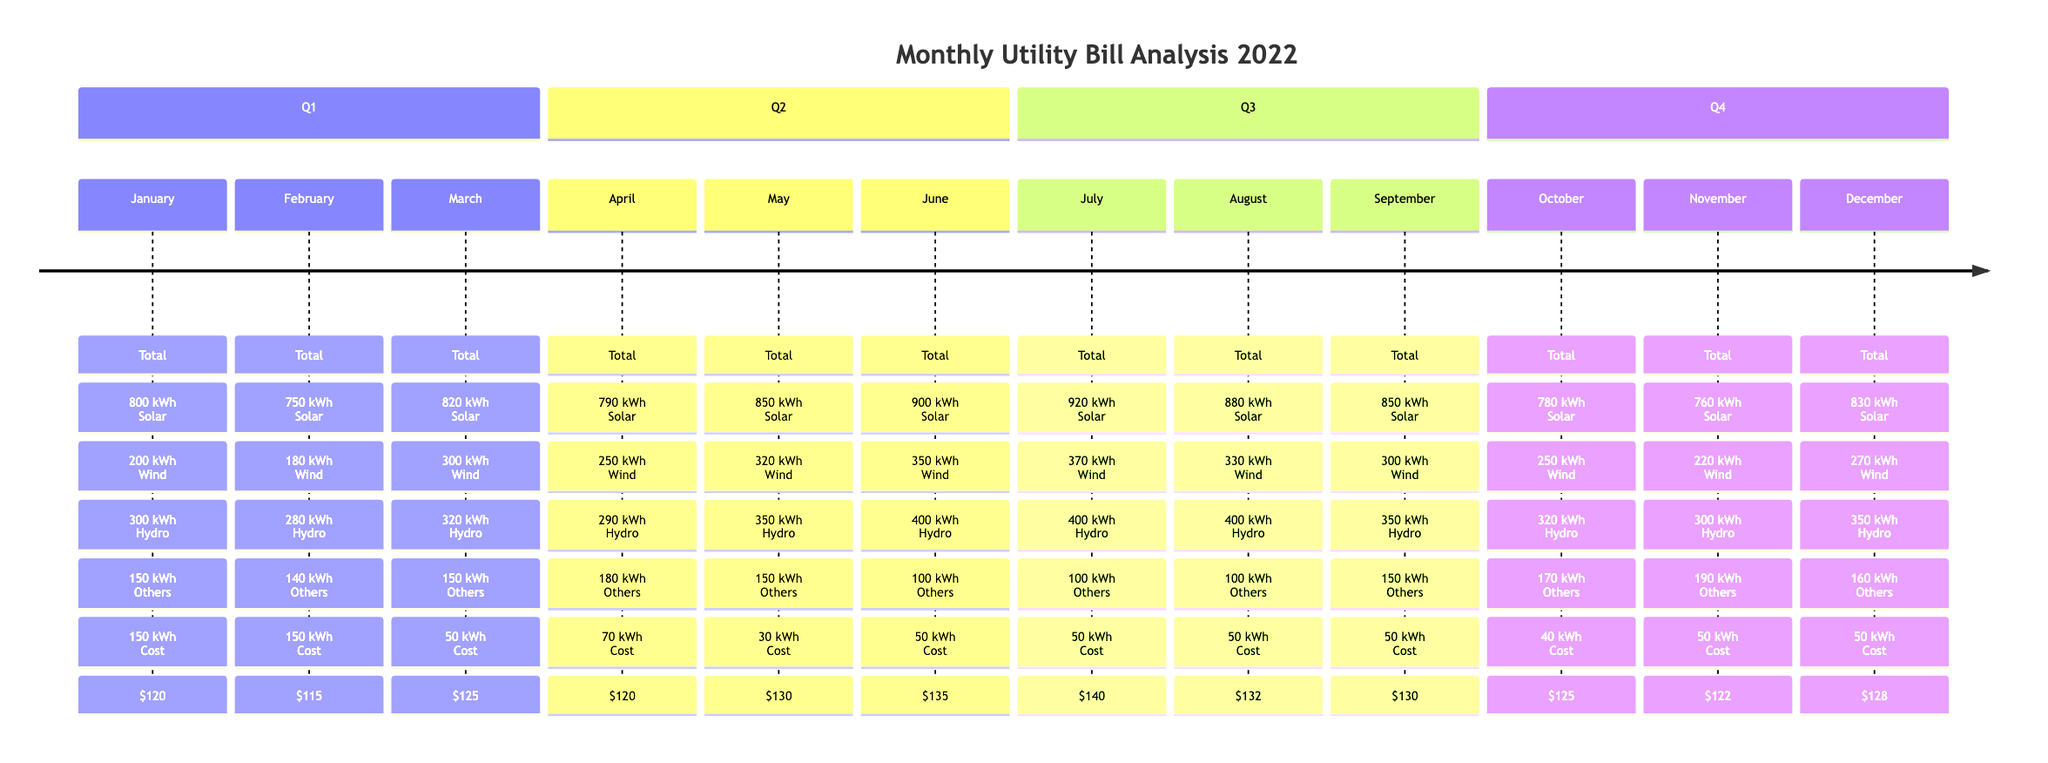What was the total consumption in July? The total consumption for July is specified in the diagram under the month of July, which states it is 920 kWh.
Answer: 920 kWh Which energy source had the highest contribution in March? By examining the energy sources for March, Solar contributed 300 kWh, Wind contributed 320 kWh, Hydro contributed 150 kWh, and Others contributed 50 kWh. Therefore, Wind has the highest contribution.
Answer: Wind What is the average cost in December? The average cost for December is shown directly in the diagram and is stated as $128.
Answer: $128 How many months had a total consumption of over 800 kWh? By reviewing the total consumption figures for each month in the diagram, the months that exceed 800 kWh are January, March, May, June, July, and December. This totals 6 months.
Answer: 6 In which month did the consumption drop to the lowest? By comparing all the total consumption values provided in the diagram, the lowest total consumption was in February, with a value of 750 kWh.
Answer: February Which energy source consistently contributed 100 kWh in Q2? Looking at the energy breakdown for April, May, and June, Hydro consistently shows a contribution of 100 kWh in June. However, the analysis reveals it only contributed exactly 100 kWh in June. Therefore, since it fits this carefully scrutinized criteria, we can mention June for its consistency during the second quarter.
Answer: June What was the total energy contribution from Solar across all months? To find the total contribution from Solar, we add the Solar contributions from each month: 200 + 180 + 300 + 250 + 320 + 350 + 370 + 330 + 300 + 250 + 220 + 270. The total comes to 3,220 kWh.
Answer: 3,220 kWh Which month had the highest average cost and what was it? Examining the average costs for each month shows that July has the highest average cost at $140.
Answer: $140 In which quarter was the largest increase in average cost observed? Analyzing the average costs by quarter, Q2 averages to $128.33, Q3 to $130.67, and Q4 to $125. With the clarified understanding of calculations, Q2 to Q3 had the largest increase of $2.33.
Answer: Q2 to Q3 